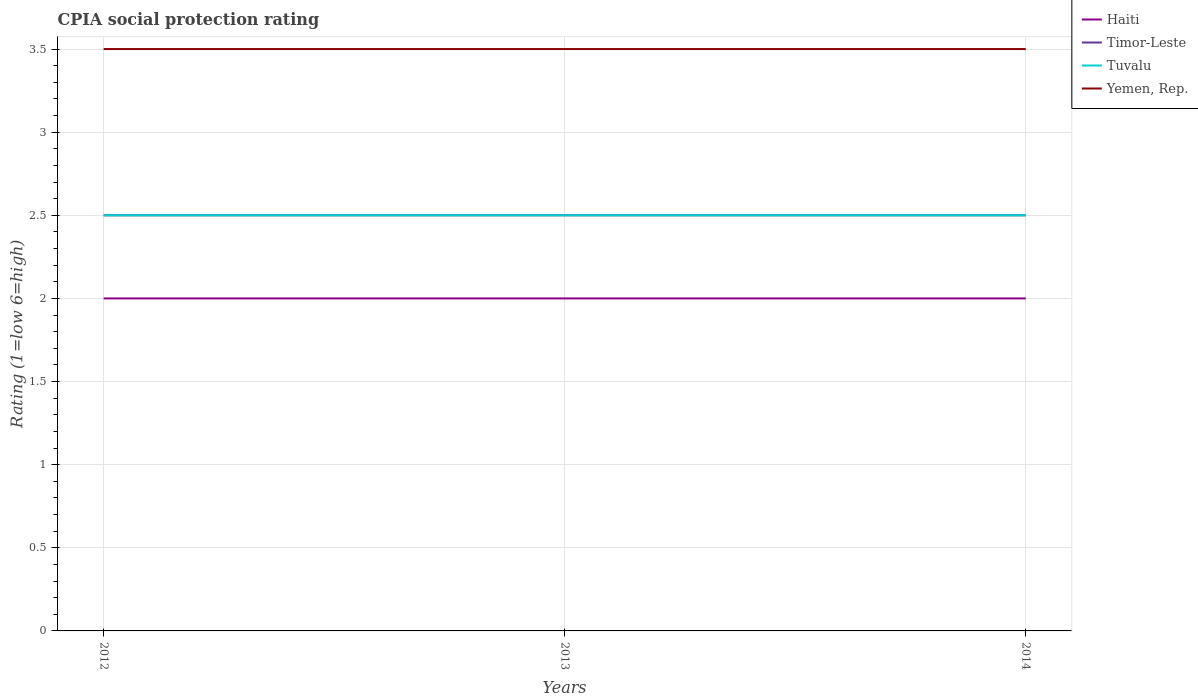Across all years, what is the maximum CPIA rating in Yemen, Rep.?
Give a very brief answer. 3.5. In which year was the CPIA rating in Haiti maximum?
Your answer should be compact. 2012. What is the total CPIA rating in Tuvalu in the graph?
Offer a terse response. 0. What is the difference between the highest and the second highest CPIA rating in Tuvalu?
Provide a short and direct response. 0. Are the values on the major ticks of Y-axis written in scientific E-notation?
Keep it short and to the point. No. Does the graph contain any zero values?
Ensure brevity in your answer.  No. Does the graph contain grids?
Give a very brief answer. Yes. How many legend labels are there?
Provide a short and direct response. 4. What is the title of the graph?
Give a very brief answer. CPIA social protection rating. Does "Solomon Islands" appear as one of the legend labels in the graph?
Make the answer very short. No. What is the label or title of the X-axis?
Offer a very short reply. Years. What is the label or title of the Y-axis?
Make the answer very short. Rating (1=low 6=high). What is the Rating (1=low 6=high) in Haiti in 2012?
Keep it short and to the point. 2. What is the Rating (1=low 6=high) of Tuvalu in 2012?
Provide a succinct answer. 2.5. What is the Rating (1=low 6=high) of Yemen, Rep. in 2012?
Your response must be concise. 3.5. What is the Rating (1=low 6=high) in Haiti in 2013?
Provide a succinct answer. 2. What is the Rating (1=low 6=high) in Timor-Leste in 2013?
Give a very brief answer. 2.5. What is the Rating (1=low 6=high) of Tuvalu in 2013?
Ensure brevity in your answer.  2.5. What is the Rating (1=low 6=high) of Haiti in 2014?
Your response must be concise. 2. What is the Rating (1=low 6=high) in Yemen, Rep. in 2014?
Offer a terse response. 3.5. Across all years, what is the maximum Rating (1=low 6=high) in Timor-Leste?
Offer a very short reply. 2.5. Across all years, what is the maximum Rating (1=low 6=high) of Yemen, Rep.?
Offer a very short reply. 3.5. Across all years, what is the minimum Rating (1=low 6=high) in Timor-Leste?
Give a very brief answer. 2.5. Across all years, what is the minimum Rating (1=low 6=high) of Tuvalu?
Offer a terse response. 2.5. Across all years, what is the minimum Rating (1=low 6=high) of Yemen, Rep.?
Your answer should be very brief. 3.5. What is the total Rating (1=low 6=high) in Haiti in the graph?
Your response must be concise. 6. What is the total Rating (1=low 6=high) in Timor-Leste in the graph?
Offer a very short reply. 7.5. What is the total Rating (1=low 6=high) of Yemen, Rep. in the graph?
Offer a terse response. 10.5. What is the difference between the Rating (1=low 6=high) of Timor-Leste in 2012 and that in 2013?
Make the answer very short. 0. What is the difference between the Rating (1=low 6=high) in Tuvalu in 2012 and that in 2013?
Keep it short and to the point. 0. What is the difference between the Rating (1=low 6=high) of Timor-Leste in 2012 and that in 2014?
Your response must be concise. 0. What is the difference between the Rating (1=low 6=high) of Tuvalu in 2012 and that in 2014?
Your answer should be compact. 0. What is the difference between the Rating (1=low 6=high) in Haiti in 2013 and that in 2014?
Provide a succinct answer. 0. What is the difference between the Rating (1=low 6=high) of Timor-Leste in 2013 and that in 2014?
Ensure brevity in your answer.  0. What is the difference between the Rating (1=low 6=high) in Tuvalu in 2013 and that in 2014?
Ensure brevity in your answer.  0. What is the difference between the Rating (1=low 6=high) of Yemen, Rep. in 2013 and that in 2014?
Keep it short and to the point. 0. What is the difference between the Rating (1=low 6=high) in Haiti in 2012 and the Rating (1=low 6=high) in Yemen, Rep. in 2013?
Offer a very short reply. -1.5. What is the difference between the Rating (1=low 6=high) in Tuvalu in 2012 and the Rating (1=low 6=high) in Yemen, Rep. in 2013?
Provide a succinct answer. -1. What is the difference between the Rating (1=low 6=high) of Haiti in 2012 and the Rating (1=low 6=high) of Timor-Leste in 2014?
Ensure brevity in your answer.  -0.5. What is the difference between the Rating (1=low 6=high) of Haiti in 2012 and the Rating (1=low 6=high) of Tuvalu in 2014?
Make the answer very short. -0.5. What is the difference between the Rating (1=low 6=high) in Haiti in 2012 and the Rating (1=low 6=high) in Yemen, Rep. in 2014?
Provide a short and direct response. -1.5. What is the difference between the Rating (1=low 6=high) in Timor-Leste in 2012 and the Rating (1=low 6=high) in Tuvalu in 2014?
Offer a terse response. 0. What is the difference between the Rating (1=low 6=high) of Timor-Leste in 2012 and the Rating (1=low 6=high) of Yemen, Rep. in 2014?
Make the answer very short. -1. What is the difference between the Rating (1=low 6=high) of Haiti in 2013 and the Rating (1=low 6=high) of Tuvalu in 2014?
Give a very brief answer. -0.5. What is the difference between the Rating (1=low 6=high) of Timor-Leste in 2013 and the Rating (1=low 6=high) of Tuvalu in 2014?
Provide a short and direct response. 0. What is the average Rating (1=low 6=high) in Haiti per year?
Provide a succinct answer. 2. What is the average Rating (1=low 6=high) in Timor-Leste per year?
Your answer should be very brief. 2.5. In the year 2012, what is the difference between the Rating (1=low 6=high) in Haiti and Rating (1=low 6=high) in Yemen, Rep.?
Ensure brevity in your answer.  -1.5. In the year 2012, what is the difference between the Rating (1=low 6=high) of Timor-Leste and Rating (1=low 6=high) of Tuvalu?
Provide a short and direct response. 0. In the year 2012, what is the difference between the Rating (1=low 6=high) of Timor-Leste and Rating (1=low 6=high) of Yemen, Rep.?
Give a very brief answer. -1. In the year 2012, what is the difference between the Rating (1=low 6=high) in Tuvalu and Rating (1=low 6=high) in Yemen, Rep.?
Provide a short and direct response. -1. In the year 2013, what is the difference between the Rating (1=low 6=high) in Tuvalu and Rating (1=low 6=high) in Yemen, Rep.?
Give a very brief answer. -1. In the year 2014, what is the difference between the Rating (1=low 6=high) in Haiti and Rating (1=low 6=high) in Timor-Leste?
Ensure brevity in your answer.  -0.5. In the year 2014, what is the difference between the Rating (1=low 6=high) in Haiti and Rating (1=low 6=high) in Yemen, Rep.?
Provide a short and direct response. -1.5. In the year 2014, what is the difference between the Rating (1=low 6=high) in Timor-Leste and Rating (1=low 6=high) in Yemen, Rep.?
Offer a very short reply. -1. In the year 2014, what is the difference between the Rating (1=low 6=high) of Tuvalu and Rating (1=low 6=high) of Yemen, Rep.?
Provide a short and direct response. -1. What is the ratio of the Rating (1=low 6=high) of Timor-Leste in 2012 to that in 2013?
Give a very brief answer. 1. What is the ratio of the Rating (1=low 6=high) in Yemen, Rep. in 2012 to that in 2013?
Give a very brief answer. 1. What is the ratio of the Rating (1=low 6=high) in Haiti in 2012 to that in 2014?
Your response must be concise. 1. What is the ratio of the Rating (1=low 6=high) of Tuvalu in 2012 to that in 2014?
Your answer should be very brief. 1. What is the ratio of the Rating (1=low 6=high) in Haiti in 2013 to that in 2014?
Make the answer very short. 1. What is the ratio of the Rating (1=low 6=high) in Timor-Leste in 2013 to that in 2014?
Provide a succinct answer. 1. What is the ratio of the Rating (1=low 6=high) in Tuvalu in 2013 to that in 2014?
Ensure brevity in your answer.  1. What is the difference between the highest and the second highest Rating (1=low 6=high) of Timor-Leste?
Offer a very short reply. 0. What is the difference between the highest and the lowest Rating (1=low 6=high) in Haiti?
Your answer should be compact. 0. 